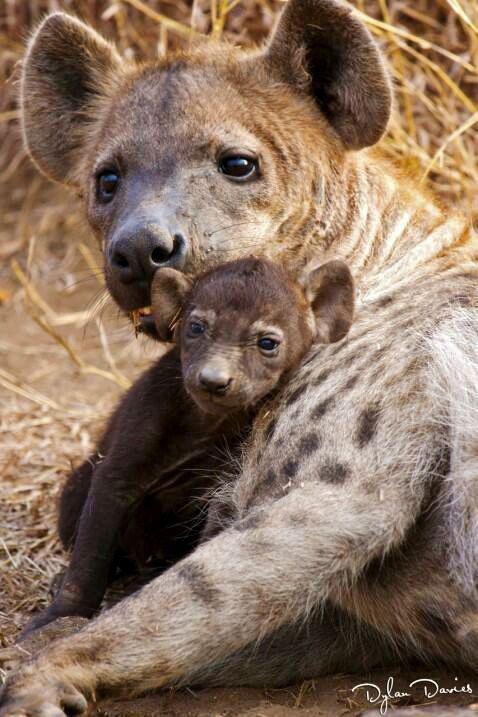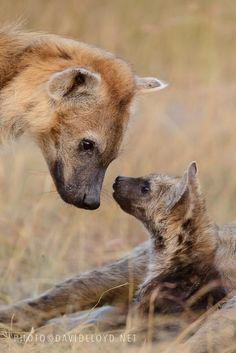The first image is the image on the left, the second image is the image on the right. Given the left and right images, does the statement "Some teeth are visible in one of the images." hold true? Answer yes or no. No. 